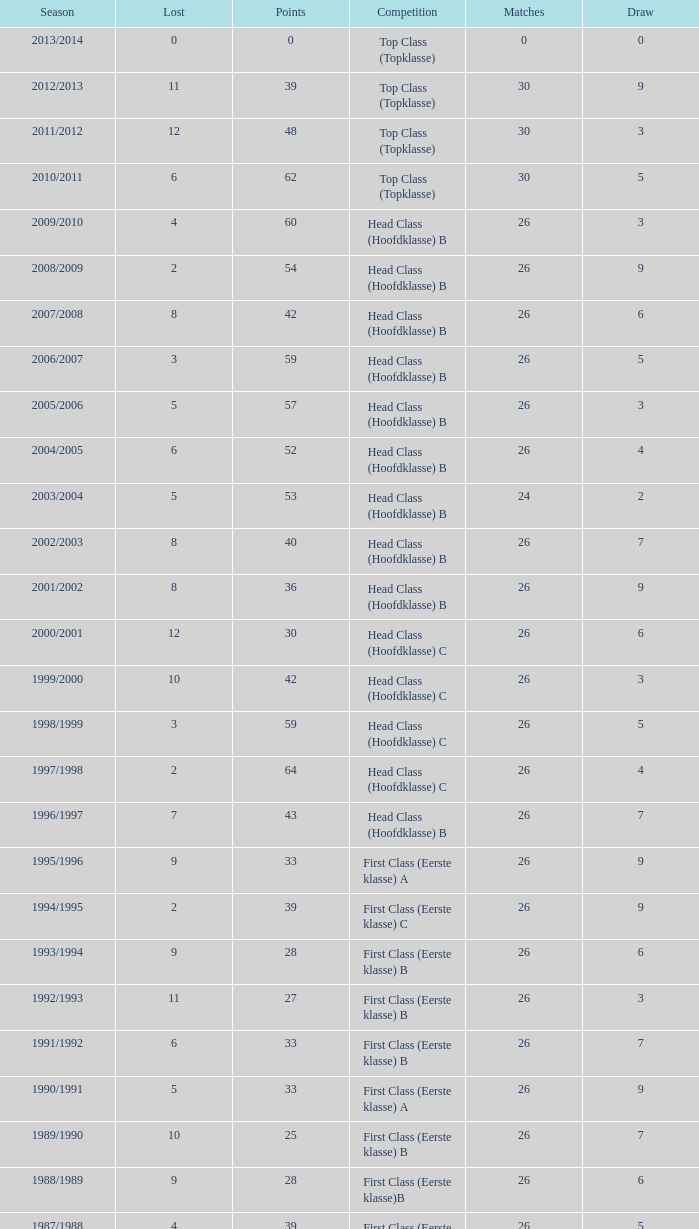What competition has a score greater than 30, a draw less than 5, and a loss larger than 10? Top Class (Topklasse). 